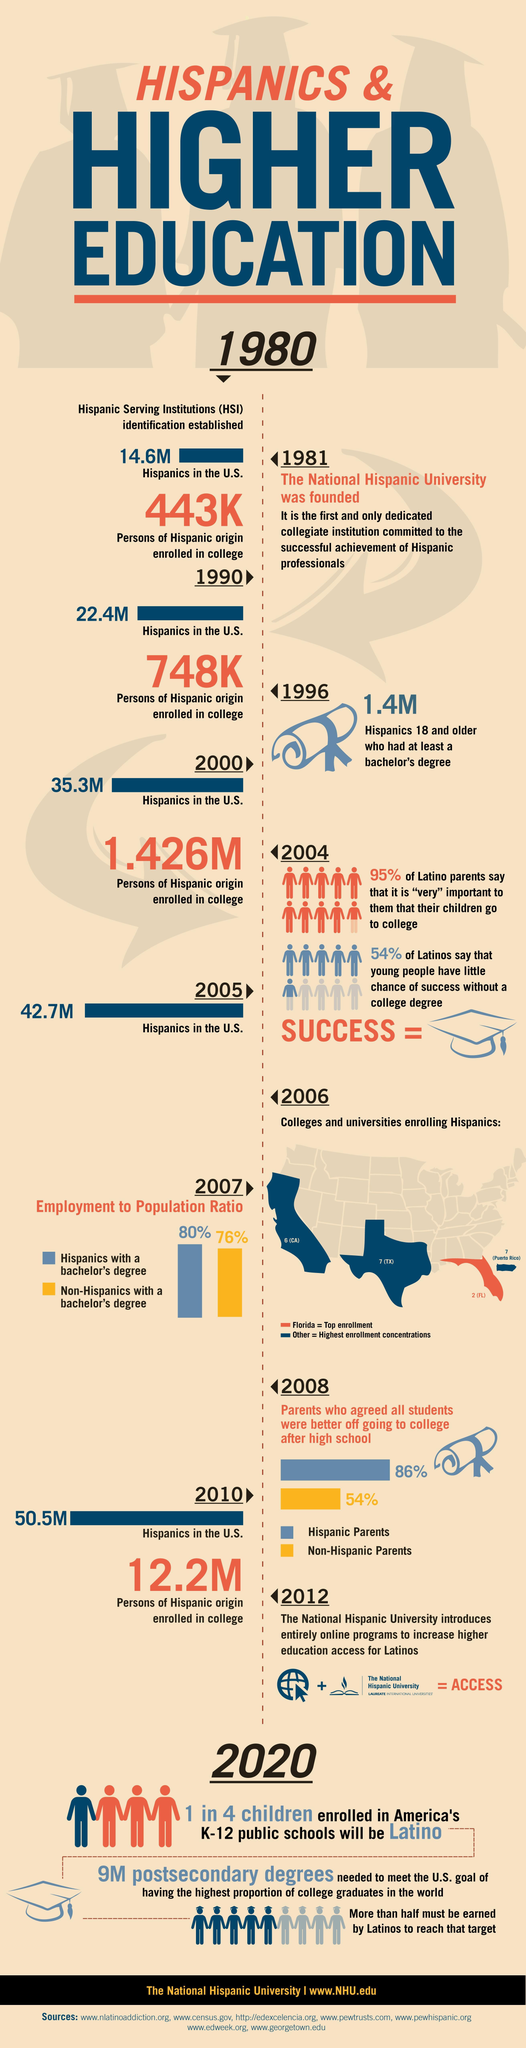What is the population of the Hispanics in the U.S. in 2005?
Answer the question with a short phrase. 42.7M What percentage of hispanics in the U.S. have a bachelor's degree in 2007? 80% What is the population of the Hispanics in the U.S. in 2010? 50.5M What population of Hispanics aged 18+ years had at least a bachelor's degree in 1996? 1.4M When was the National Hispanic University founded? 1981 What percentage of hispanic parents in the U.S. agreed that all students were better off going to college after high schools in 2008? 86% What is the population of the Hispanics in the U.S. in 1981? 14.6M What percentage of non-hispanics in the U.S. have a bachelor's degree in 2007? 76% 